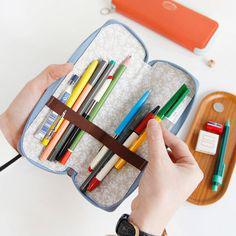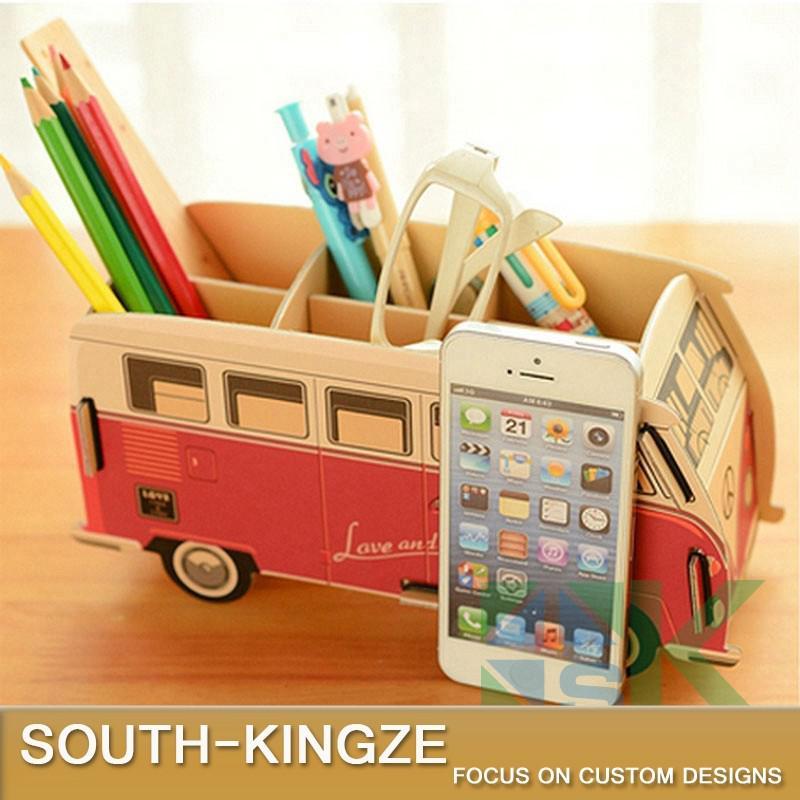The first image is the image on the left, the second image is the image on the right. For the images displayed, is the sentence "There are no writing utensils visible in one of the pictures." factually correct? Answer yes or no. No. The first image is the image on the left, the second image is the image on the right. Analyze the images presented: Is the assertion "there are pencils with the erasers side up" valid? Answer yes or no. Yes. 